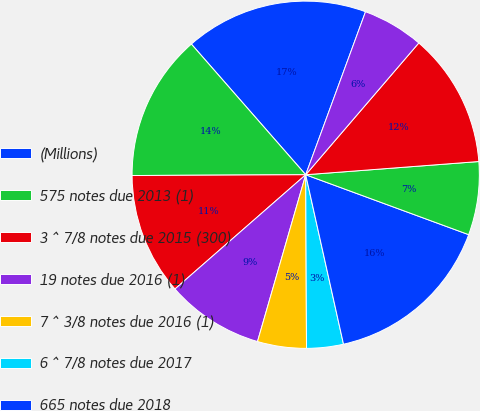Convert chart to OTSL. <chart><loc_0><loc_0><loc_500><loc_500><pie_chart><fcel>(Millions)<fcel>575 notes due 2013 (1)<fcel>3 ^ 7/8 notes due 2015 (300)<fcel>19 notes due 2016 (1)<fcel>7 ^ 3/8 notes due 2016 (1)<fcel>6 ^ 7/8 notes due 2017<fcel>665 notes due 2018<fcel>74 notes due 2019<fcel>36 notes due 2020<fcel>9 non-callable debentures due<nl><fcel>17.04%<fcel>13.63%<fcel>11.36%<fcel>9.09%<fcel>4.55%<fcel>3.42%<fcel>15.9%<fcel>6.82%<fcel>12.5%<fcel>5.69%<nl></chart> 